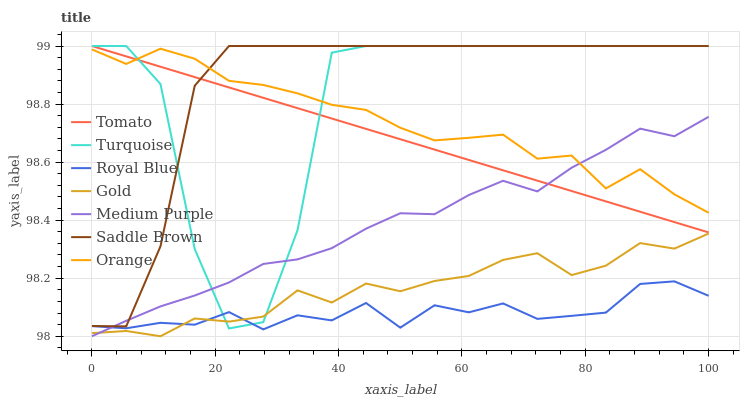Does Royal Blue have the minimum area under the curve?
Answer yes or no. Yes. Does Saddle Brown have the maximum area under the curve?
Answer yes or no. Yes. Does Turquoise have the minimum area under the curve?
Answer yes or no. No. Does Turquoise have the maximum area under the curve?
Answer yes or no. No. Is Tomato the smoothest?
Answer yes or no. Yes. Is Turquoise the roughest?
Answer yes or no. Yes. Is Gold the smoothest?
Answer yes or no. No. Is Gold the roughest?
Answer yes or no. No. Does Gold have the lowest value?
Answer yes or no. Yes. Does Turquoise have the lowest value?
Answer yes or no. No. Does Saddle Brown have the highest value?
Answer yes or no. Yes. Does Gold have the highest value?
Answer yes or no. No. Is Royal Blue less than Tomato?
Answer yes or no. Yes. Is Orange greater than Royal Blue?
Answer yes or no. Yes. Does Gold intersect Turquoise?
Answer yes or no. Yes. Is Gold less than Turquoise?
Answer yes or no. No. Is Gold greater than Turquoise?
Answer yes or no. No. Does Royal Blue intersect Tomato?
Answer yes or no. No. 